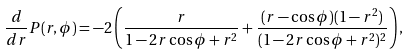Convert formula to latex. <formula><loc_0><loc_0><loc_500><loc_500>\frac { d } { d r } P ( r , \phi ) = - 2 \left ( \frac { r } { 1 - 2 r \cos \phi + r ^ { 2 } } + \frac { ( r - \cos \phi ) ( 1 - r ^ { 2 } ) } { ( 1 - 2 r \cos \phi + r ^ { 2 } ) ^ { 2 } } \right ) ,</formula> 